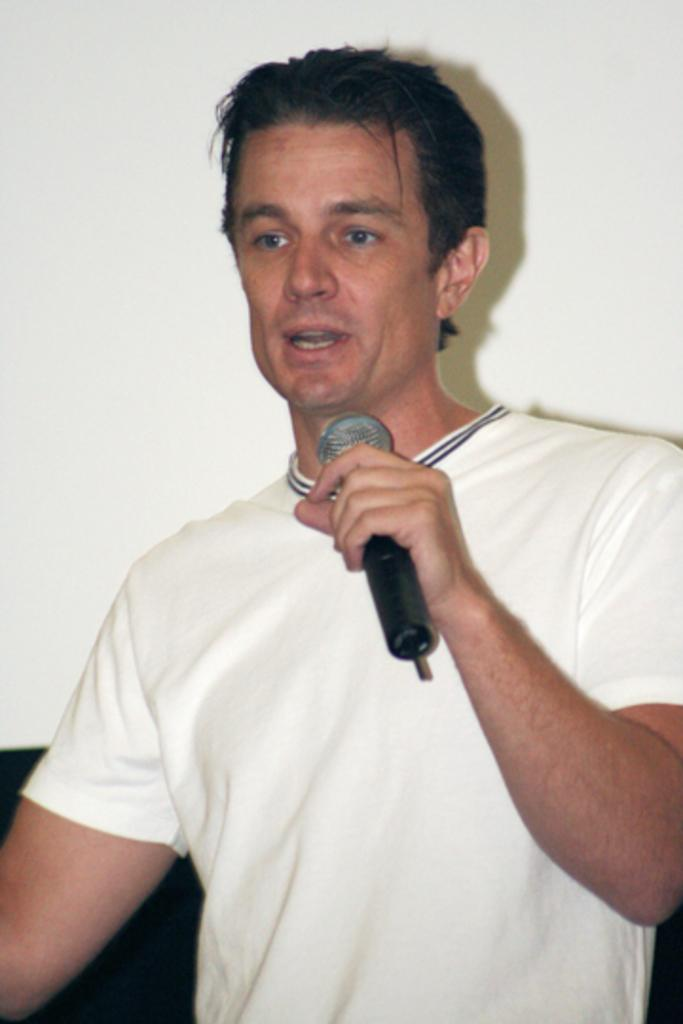Who is the main subject in the image? There is a man in the image. What is the man wearing? The man is wearing a white T-shirt. What is the man doing in the image? The man is standing and talking. What object is the man holding in the image? The man is holding a microphone. What is the color of the background in the image? The background of the image is white. What flavor of engine can be seen in the image? There is no engine present in the image, and therefore no flavor can be determined. 